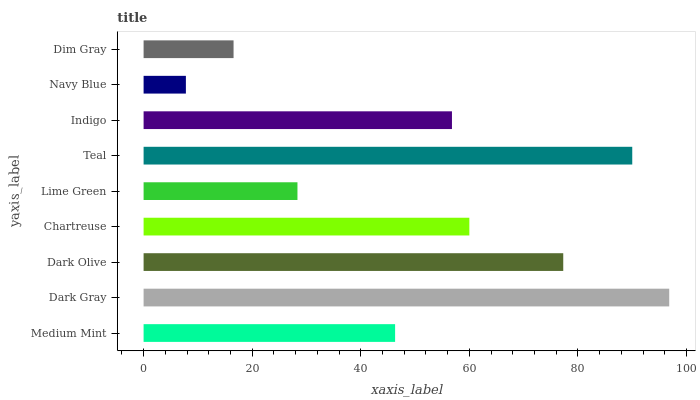Is Navy Blue the minimum?
Answer yes or no. Yes. Is Dark Gray the maximum?
Answer yes or no. Yes. Is Dark Olive the minimum?
Answer yes or no. No. Is Dark Olive the maximum?
Answer yes or no. No. Is Dark Gray greater than Dark Olive?
Answer yes or no. Yes. Is Dark Olive less than Dark Gray?
Answer yes or no. Yes. Is Dark Olive greater than Dark Gray?
Answer yes or no. No. Is Dark Gray less than Dark Olive?
Answer yes or no. No. Is Indigo the high median?
Answer yes or no. Yes. Is Indigo the low median?
Answer yes or no. Yes. Is Dark Gray the high median?
Answer yes or no. No. Is Dim Gray the low median?
Answer yes or no. No. 